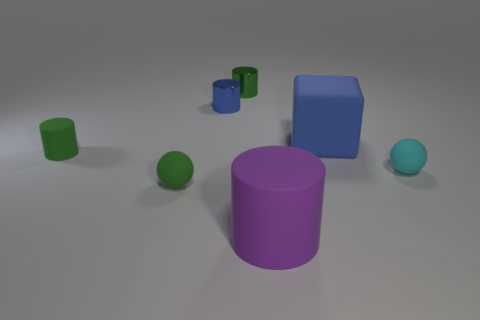What is the shape of the blue shiny object that is the same size as the cyan ball?
Make the answer very short. Cylinder. Are there any green objects of the same size as the green ball?
Your response must be concise. Yes. There is a cylinder that is the same size as the blue cube; what is its material?
Keep it short and to the point. Rubber. There is a cyan matte thing in front of the green cylinder that is in front of the large blue block; how big is it?
Give a very brief answer. Small. There is a blue thing on the left side of the block; does it have the same size as the large cube?
Your answer should be compact. No. Is the number of tiny blue objects in front of the cyan sphere greater than the number of large cylinders left of the tiny green shiny thing?
Offer a very short reply. No. The tiny matte thing that is both in front of the small green rubber cylinder and on the left side of the large purple rubber thing has what shape?
Your answer should be compact. Sphere. There is a large matte thing that is left of the large blue object; what is its shape?
Keep it short and to the point. Cylinder. There is a metallic cylinder left of the green cylinder behind the big thing behind the tiny cyan matte object; how big is it?
Your answer should be very brief. Small. Is the shape of the small cyan thing the same as the blue metal object?
Make the answer very short. No. 